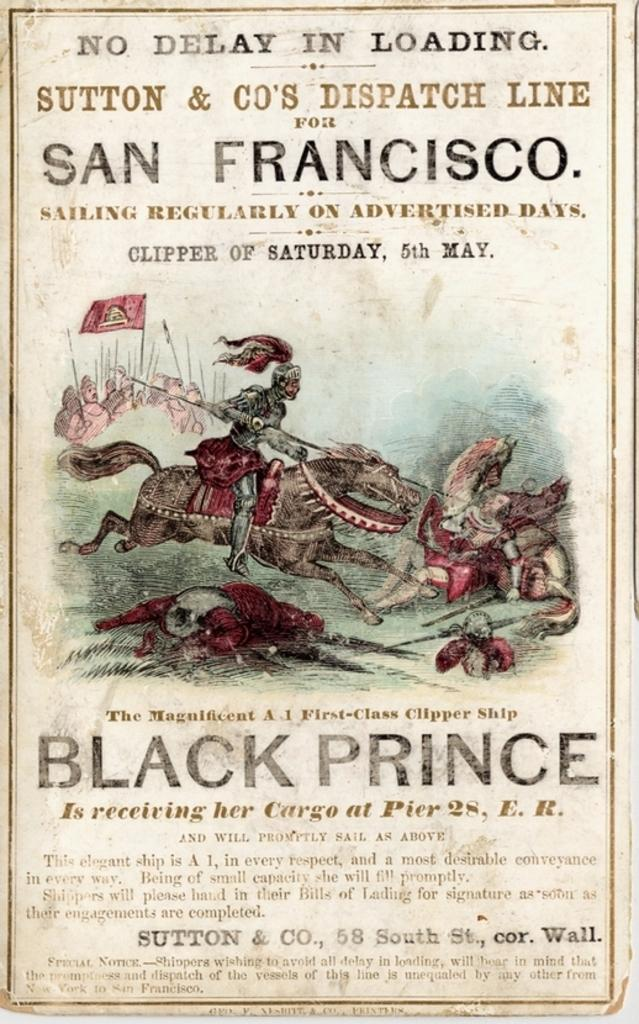<image>
Relay a brief, clear account of the picture shown. Poster containing text saying: No Delay in Loading, Sutton & Co;s Dispatch Line, San Francisco. 